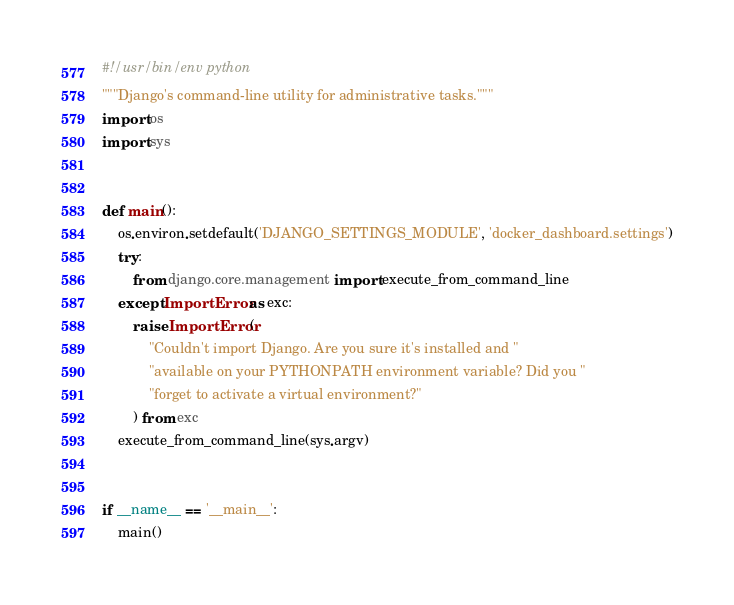<code> <loc_0><loc_0><loc_500><loc_500><_Python_>#!/usr/bin/env python
"""Django's command-line utility for administrative tasks."""
import os
import sys


def main():
    os.environ.setdefault('DJANGO_SETTINGS_MODULE', 'docker_dashboard.settings')
    try:
        from django.core.management import execute_from_command_line
    except ImportError as exc:
        raise ImportError(
            "Couldn't import Django. Are you sure it's installed and "
            "available on your PYTHONPATH environment variable? Did you "
            "forget to activate a virtual environment?"
        ) from exc
    execute_from_command_line(sys.argv)


if __name__ == '__main__':
    main()
</code> 